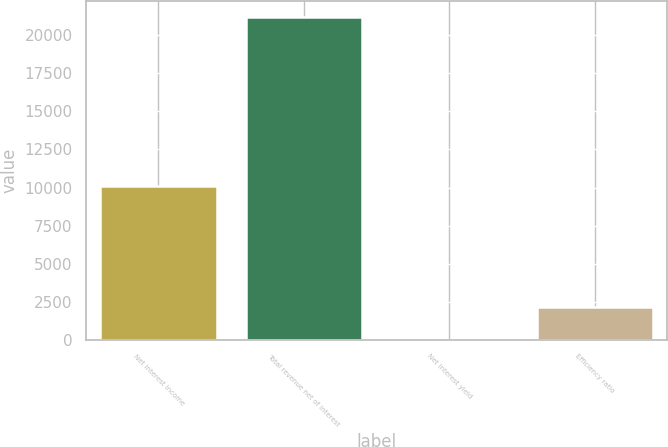Convert chart. <chart><loc_0><loc_0><loc_500><loc_500><bar_chart><fcel>Net interest income<fcel>Total revenue net of interest<fcel>Net interest yield<fcel>Efficiency ratio<nl><fcel>10127<fcel>21219<fcel>2.19<fcel>2123.87<nl></chart> 